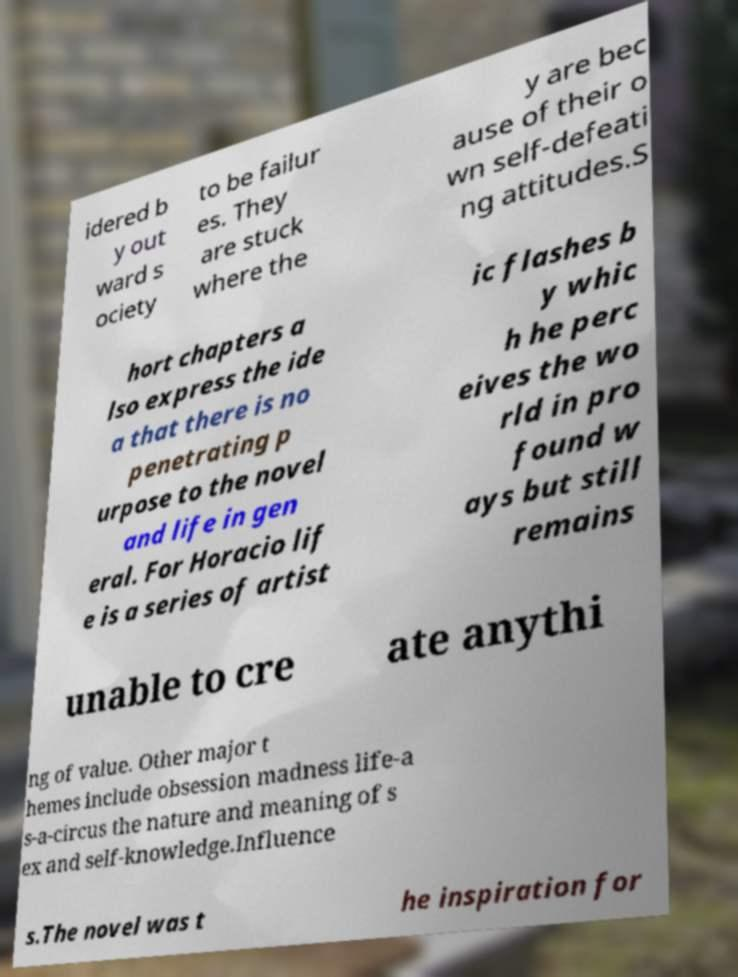Can you read and provide the text displayed in the image?This photo seems to have some interesting text. Can you extract and type it out for me? idered b y out ward s ociety to be failur es. They are stuck where the y are bec ause of their o wn self-defeati ng attitudes.S hort chapters a lso express the ide a that there is no penetrating p urpose to the novel and life in gen eral. For Horacio lif e is a series of artist ic flashes b y whic h he perc eives the wo rld in pro found w ays but still remains unable to cre ate anythi ng of value. Other major t hemes include obsession madness life-a s-a-circus the nature and meaning of s ex and self-knowledge.Influence s.The novel was t he inspiration for 